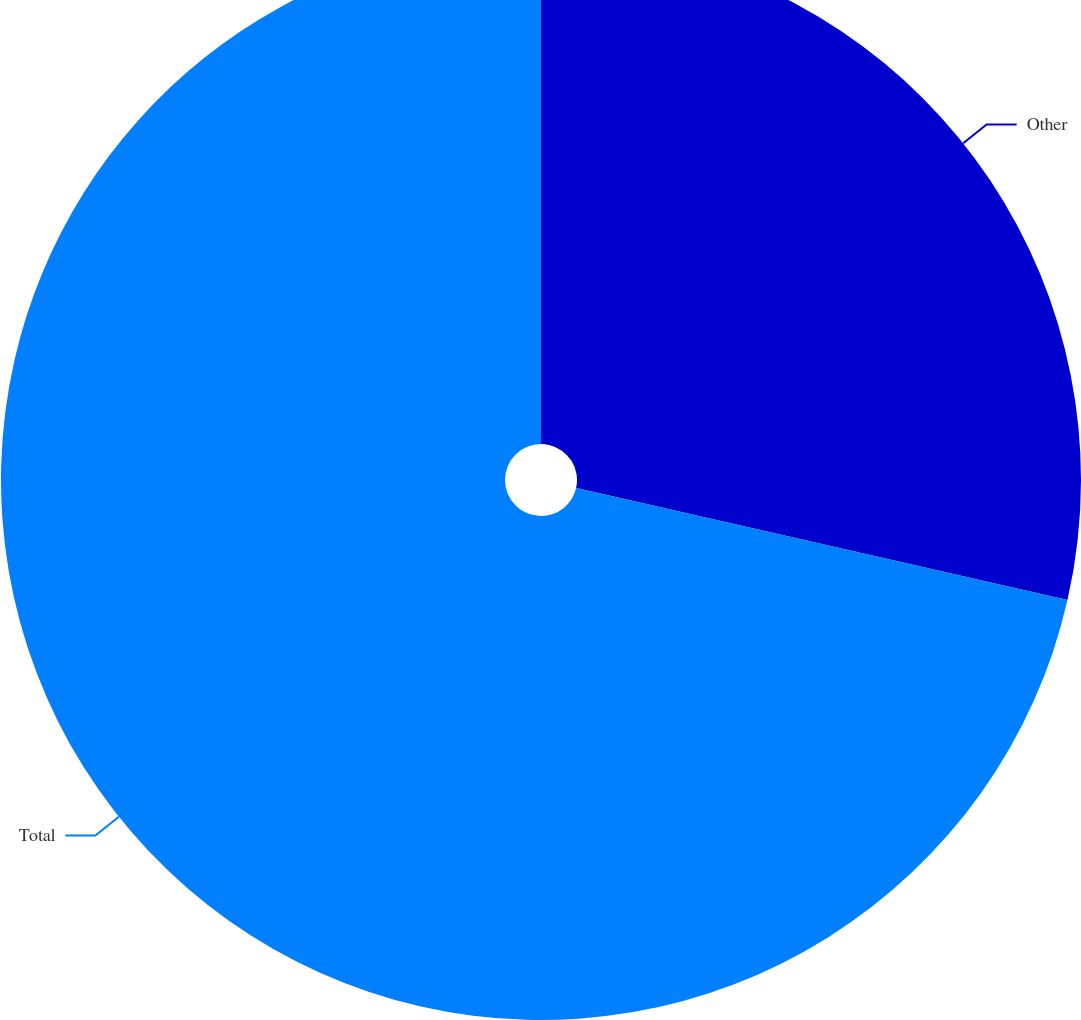Convert chart to OTSL. <chart><loc_0><loc_0><loc_500><loc_500><pie_chart><fcel>Other<fcel>Total<nl><fcel>28.57%<fcel>71.43%<nl></chart> 